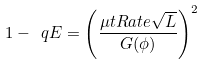<formula> <loc_0><loc_0><loc_500><loc_500>1 - \ q E = \left ( \frac { \mu t R a t e \sqrt { L } } { G ( \phi ) } \right ) ^ { 2 }</formula> 